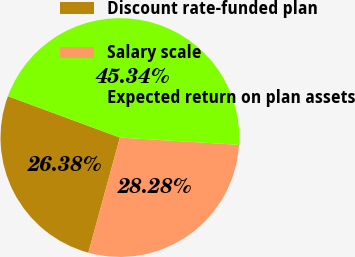Convert chart to OTSL. <chart><loc_0><loc_0><loc_500><loc_500><pie_chart><fcel>Discount rate-funded plan<fcel>Salary scale<fcel>Expected return on plan assets<nl><fcel>26.38%<fcel>28.28%<fcel>45.34%<nl></chart> 